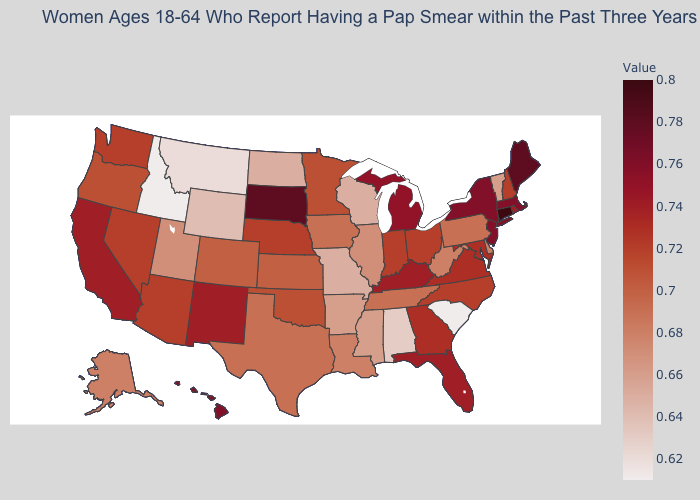Does Indiana have the lowest value in the USA?
Keep it brief. No. Does North Carolina have a higher value than Missouri?
Write a very short answer. Yes. Does Idaho have the lowest value in the USA?
Concise answer only. Yes. Is the legend a continuous bar?
Short answer required. Yes. Which states have the highest value in the USA?
Quick response, please. Connecticut. 